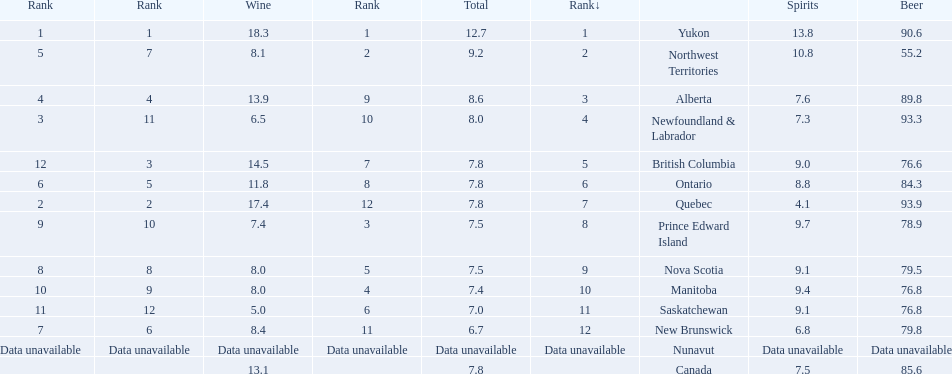Which country ranks #1 in alcoholic beverage consumption? Yukon. Of that country, how many total liters of spirits do they consume? 12.7. 